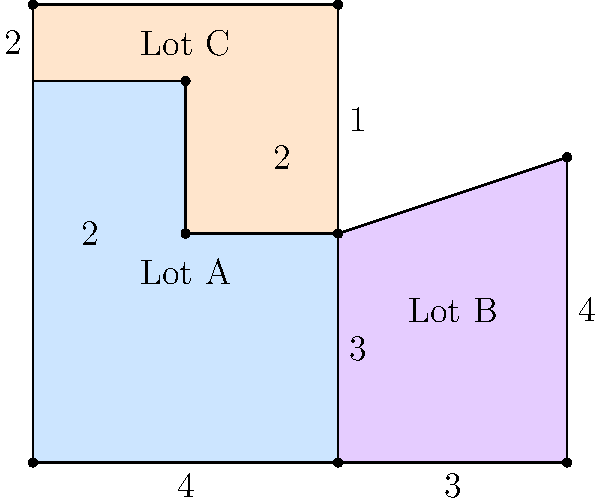In a redevelopment zone, three irregular-shaped lots (A, B, and C) are being considered for renovation. Given the dimensions shown in the diagram (in hundreds of square feet), calculate the total area of all three lots combined. How might this information be useful in planning the neighborhood revitalization? To calculate the total area, we'll find the area of each lot separately and then sum them up:

1. Lot A:
   - Divide into a rectangle (4 x 3) and a rectangle (2 x 2)
   - Area of Lot A = $(4 \times 3) + (2 \times 2) = 12 + 4 = 16$ hundred sq ft

2. Lot B:
   - This is a trapezoid
   - Area of trapezoid = $\frac{1}{2}(b_1 + b_2)h$
   - Area of Lot B = $\frac{1}{2}(3 + 4) \times 4 = \frac{7}{2} \times 4 = 14$ hundred sq ft

3. Lot C:
   - Divide into a rectangle (4 x 1) and a rectangle (2 x 2)
   - Area of Lot C = $(4 \times 1) + (2 \times 2) = 4 + 4 = 8$ hundred sq ft

4. Total Area:
   - Sum of all lots = $16 + 14 + 8 = 38$ hundred sq ft
   - Converting to actual square feet: $38 \times 100 = 3,800$ sq ft

This information is crucial for urban development as it helps in:
1. Determining the scale of the renovation project
2. Estimating costs and resources needed
3. Planning for green spaces, parking, or other amenities
4. Assessing the potential impact on population density
5. Calculating the possible return on investment for the revitalization effort
Answer: 3,800 square feet 